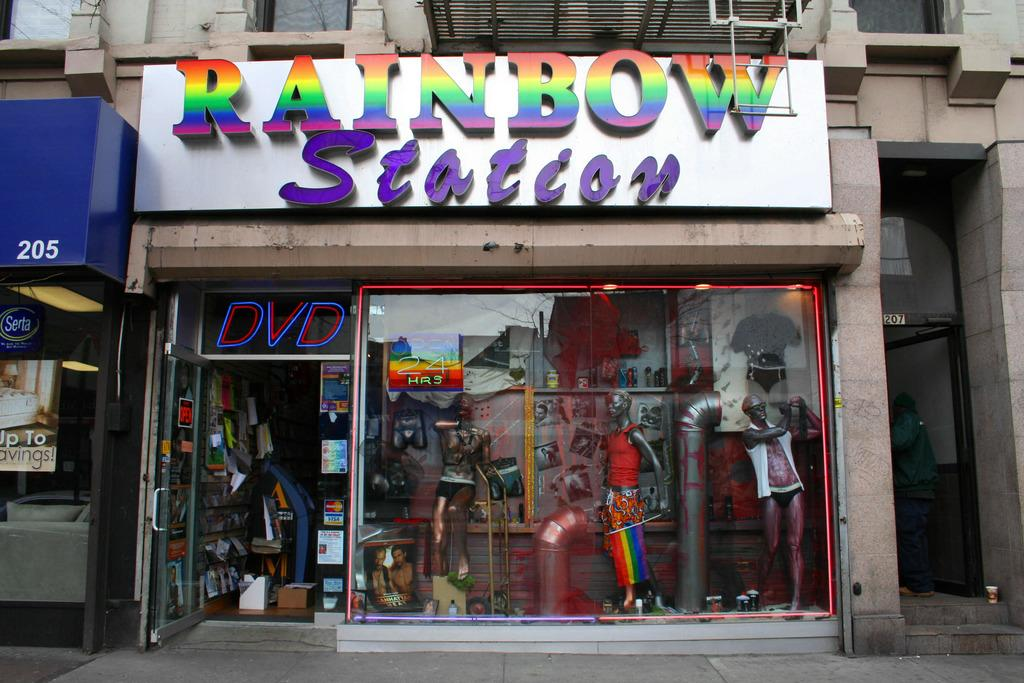<image>
Create a compact narrative representing the image presented. The front of a the store named Rainbow Station showing the display window. 